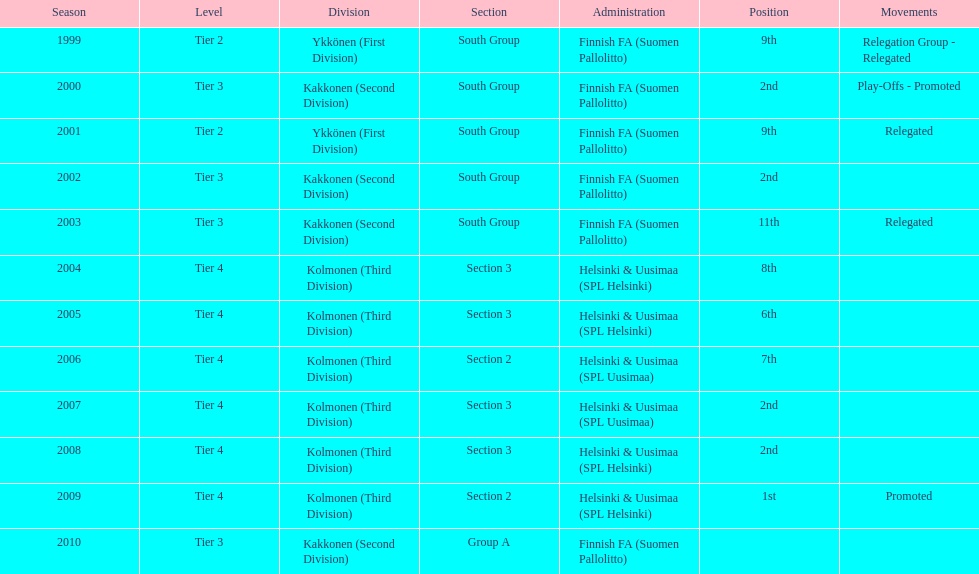When was the last year they placed 2nd? 2008. 